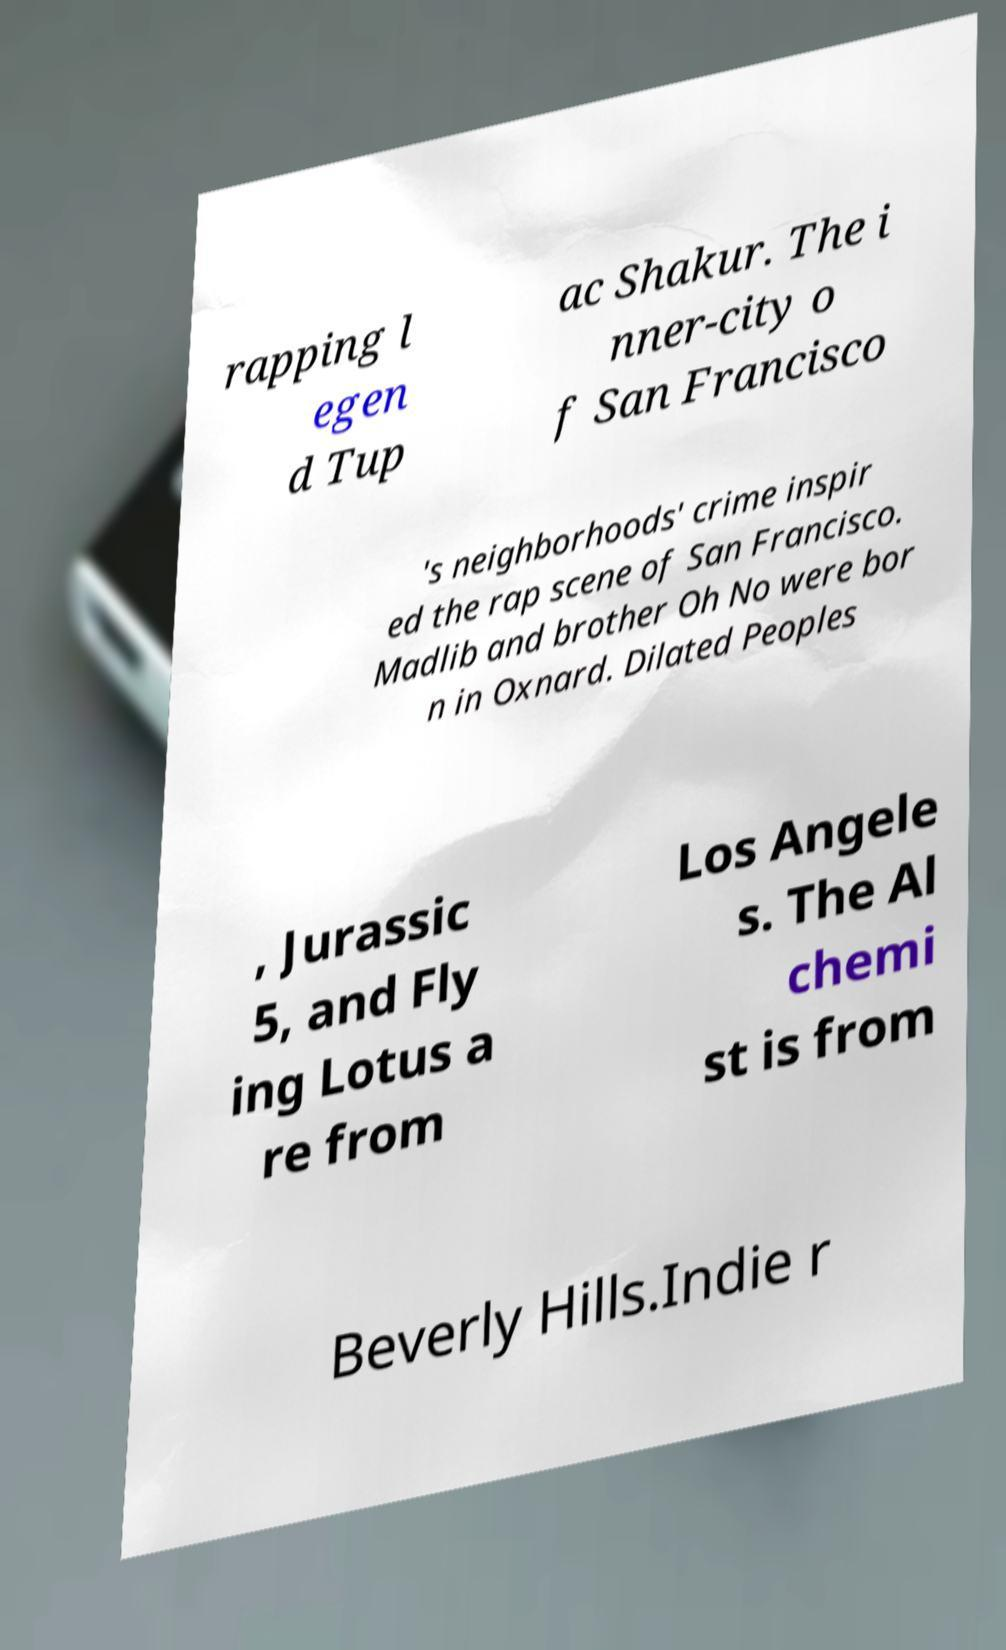Could you assist in decoding the text presented in this image and type it out clearly? rapping l egen d Tup ac Shakur. The i nner-city o f San Francisco 's neighborhoods' crime inspir ed the rap scene of San Francisco. Madlib and brother Oh No were bor n in Oxnard. Dilated Peoples , Jurassic 5, and Fly ing Lotus a re from Los Angele s. The Al chemi st is from Beverly Hills.Indie r 